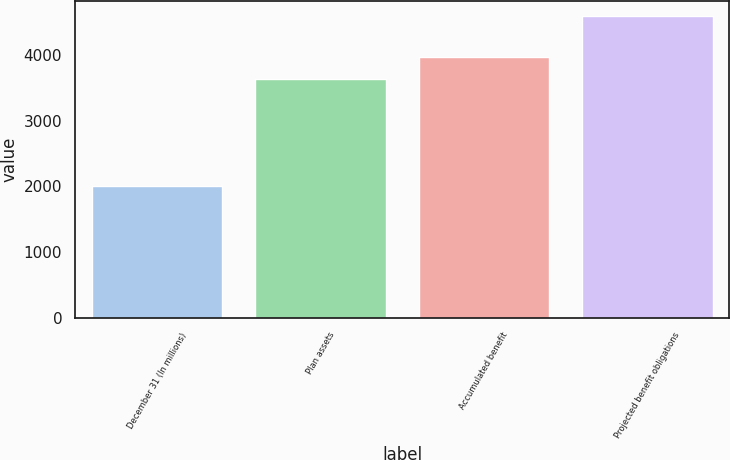Convert chart. <chart><loc_0><loc_0><loc_500><loc_500><bar_chart><fcel>December 31 (In millions)<fcel>Plan assets<fcel>Accumulated benefit<fcel>Projected benefit obligations<nl><fcel>2007<fcel>3639<fcel>3974<fcel>4595<nl></chart> 